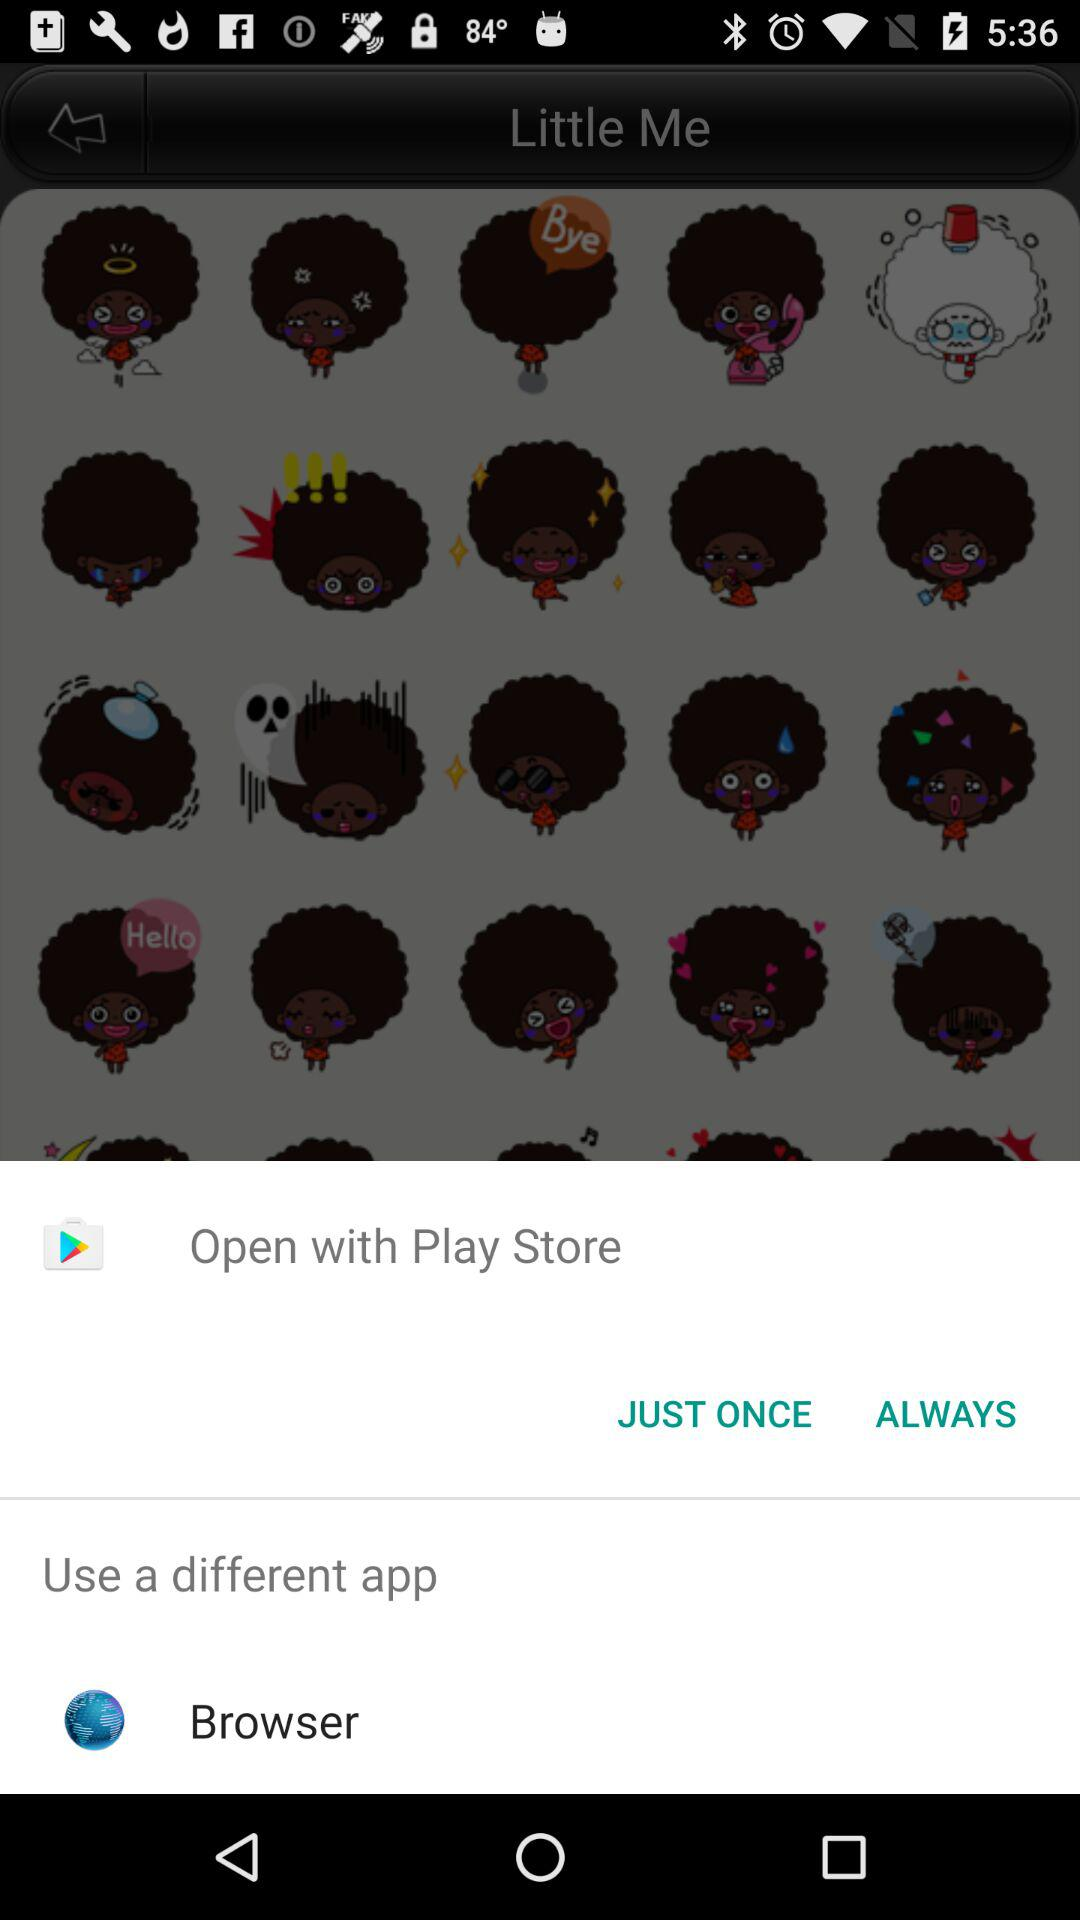Which application can I use to open the content? You can use the applications "Play Store" and "Browser". 